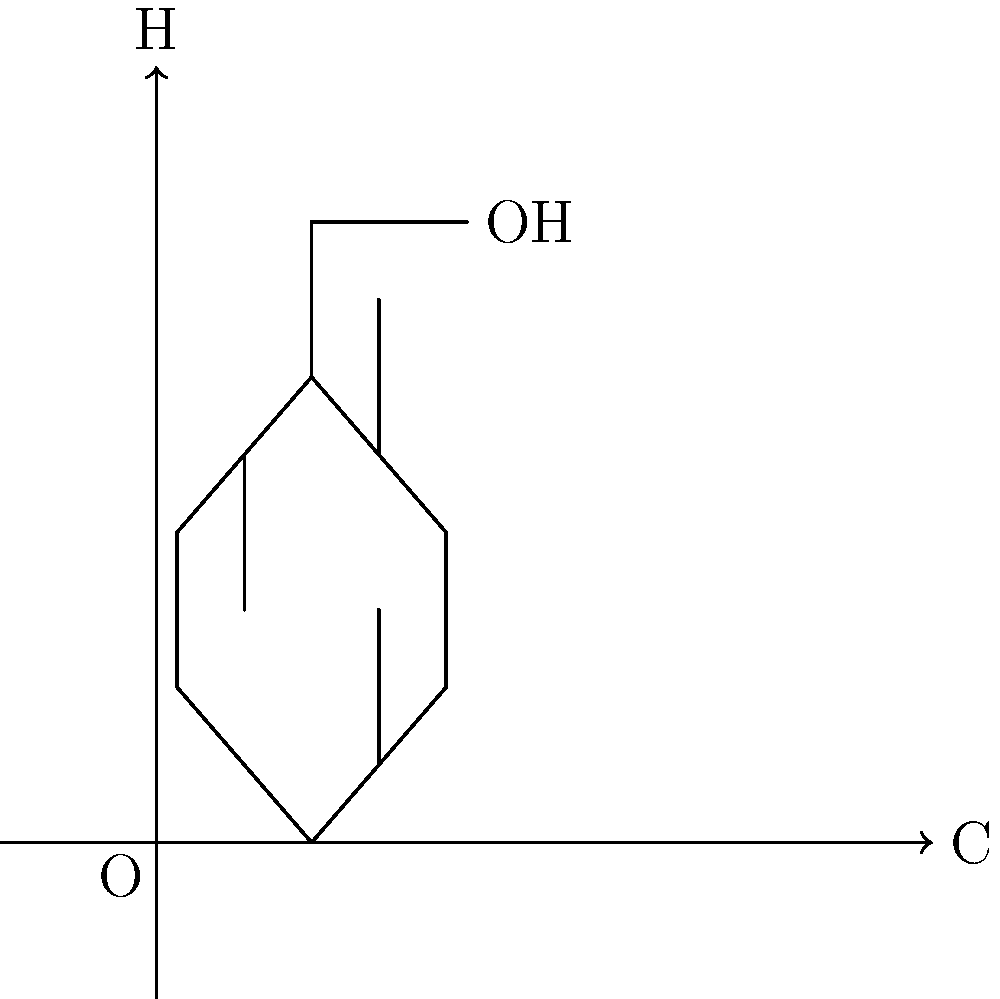Analyze the molecular structure of the essential oil component shown above. How does the presence of the hydroxyl (OH) group attached to the benzene ring contribute to its potential therapeutic properties in aromatherapy? Explain the relationship between this structure and its likely interactions with human olfactory receptors. 1. Molecular Structure Identification:
   The diagram shows a benzene ring (C6H6) with a hydroxyl (OH) group attached, forming a phenol structure.

2. Phenol Properties:
   Phenols are known for their antioxidant and antimicrobial properties, which contribute to their therapeutic effects.

3. Hydroxyl Group Significance:
   The OH group creates a polar region in the molecule, allowing for hydrogen bonding. This affects:
   a) Solubility: Increases water solubility compared to pure hydrocarbons.
   b) Reactivity: Makes the molecule more reactive in biological systems.

4. Aromatherapy Relevance:
   Essential oils with phenolic compounds often have strong aromas and potent therapeutic properties.

5. Olfactory Receptor Interaction:
   a) The polar OH group can interact with polar regions of olfactory receptors.
   b) The nonpolar benzene ring can interact with hydrophobic regions of the receptors.
   c) This dual nature allows for strong binding to olfactory receptors, potentially enhancing the aromatic effect.

6. Therapeutic Implications:
   a) Antioxidant effects: The OH group can donate a hydrogen atom, neutralizing free radicals.
   b) Antimicrobial activity: Phenols can disrupt bacterial cell membranes.
   c) Anti-inflammatory properties: Some phenols modulate inflammatory responses.

7. Structure-Activity Relationship:
   The position of the OH group on the benzene ring can affect the strength and type of therapeutic properties, influencing how it interacts with biological targets.
Answer: The hydroxyl group enhances water solubility, reactivity, and receptor binding, contributing to antioxidant, antimicrobial, and anti-inflammatory properties in aromatherapy. 